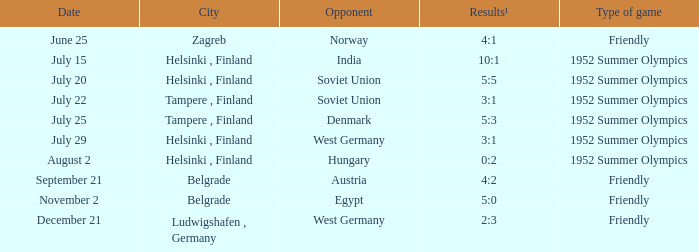What Type of game was played on Date of July 29? 1952 Summer Olympics. 